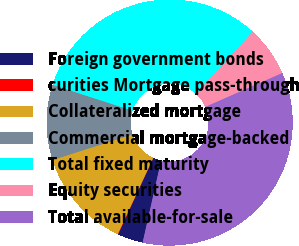Convert chart to OTSL. <chart><loc_0><loc_0><loc_500><loc_500><pie_chart><fcel>Foreign government bonds<fcel>curities Mortgage pass-through<fcel>Collateralized mortgage<fcel>Commercial mortgage-backed<fcel>Total fixed maturity<fcel>Equity securities<fcel>Total available-for-sale<nl><fcel>3.34%<fcel>0.07%<fcel>13.15%<fcel>9.88%<fcel>31.84%<fcel>6.61%<fcel>35.11%<nl></chart> 